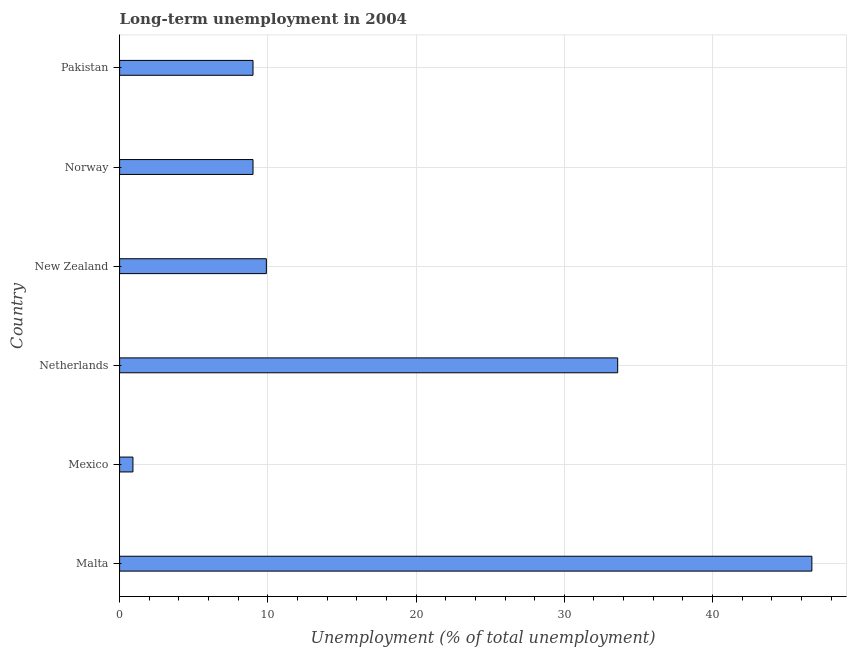Does the graph contain any zero values?
Provide a succinct answer. No. What is the title of the graph?
Your response must be concise. Long-term unemployment in 2004. What is the label or title of the X-axis?
Your answer should be very brief. Unemployment (% of total unemployment). What is the label or title of the Y-axis?
Make the answer very short. Country. What is the long-term unemployment in Mexico?
Ensure brevity in your answer.  0.9. Across all countries, what is the maximum long-term unemployment?
Ensure brevity in your answer.  46.7. Across all countries, what is the minimum long-term unemployment?
Your answer should be compact. 0.9. In which country was the long-term unemployment maximum?
Ensure brevity in your answer.  Malta. In which country was the long-term unemployment minimum?
Make the answer very short. Mexico. What is the sum of the long-term unemployment?
Provide a succinct answer. 109.1. What is the average long-term unemployment per country?
Your answer should be very brief. 18.18. What is the median long-term unemployment?
Give a very brief answer. 9.45. What is the ratio of the long-term unemployment in Mexico to that in Norway?
Offer a very short reply. 0.1. What is the difference between the highest and the second highest long-term unemployment?
Offer a very short reply. 13.1. Is the sum of the long-term unemployment in Netherlands and New Zealand greater than the maximum long-term unemployment across all countries?
Offer a terse response. No. What is the difference between the highest and the lowest long-term unemployment?
Make the answer very short. 45.8. In how many countries, is the long-term unemployment greater than the average long-term unemployment taken over all countries?
Your response must be concise. 2. Are all the bars in the graph horizontal?
Ensure brevity in your answer.  Yes. How many countries are there in the graph?
Your answer should be compact. 6. Are the values on the major ticks of X-axis written in scientific E-notation?
Ensure brevity in your answer.  No. What is the Unemployment (% of total unemployment) in Malta?
Give a very brief answer. 46.7. What is the Unemployment (% of total unemployment) of Mexico?
Keep it short and to the point. 0.9. What is the Unemployment (% of total unemployment) in Netherlands?
Your answer should be compact. 33.6. What is the Unemployment (% of total unemployment) of New Zealand?
Your answer should be compact. 9.9. What is the Unemployment (% of total unemployment) in Norway?
Keep it short and to the point. 9. What is the difference between the Unemployment (% of total unemployment) in Malta and Mexico?
Offer a very short reply. 45.8. What is the difference between the Unemployment (% of total unemployment) in Malta and New Zealand?
Your response must be concise. 36.8. What is the difference between the Unemployment (% of total unemployment) in Malta and Norway?
Ensure brevity in your answer.  37.7. What is the difference between the Unemployment (% of total unemployment) in Malta and Pakistan?
Offer a terse response. 37.7. What is the difference between the Unemployment (% of total unemployment) in Mexico and Netherlands?
Your answer should be very brief. -32.7. What is the difference between the Unemployment (% of total unemployment) in Netherlands and New Zealand?
Your answer should be very brief. 23.7. What is the difference between the Unemployment (% of total unemployment) in Netherlands and Norway?
Your response must be concise. 24.6. What is the difference between the Unemployment (% of total unemployment) in Netherlands and Pakistan?
Your response must be concise. 24.6. What is the difference between the Unemployment (% of total unemployment) in New Zealand and Norway?
Provide a succinct answer. 0.9. What is the difference between the Unemployment (% of total unemployment) in New Zealand and Pakistan?
Provide a succinct answer. 0.9. What is the difference between the Unemployment (% of total unemployment) in Norway and Pakistan?
Your answer should be very brief. 0. What is the ratio of the Unemployment (% of total unemployment) in Malta to that in Mexico?
Offer a terse response. 51.89. What is the ratio of the Unemployment (% of total unemployment) in Malta to that in Netherlands?
Offer a very short reply. 1.39. What is the ratio of the Unemployment (% of total unemployment) in Malta to that in New Zealand?
Keep it short and to the point. 4.72. What is the ratio of the Unemployment (% of total unemployment) in Malta to that in Norway?
Provide a succinct answer. 5.19. What is the ratio of the Unemployment (% of total unemployment) in Malta to that in Pakistan?
Your answer should be very brief. 5.19. What is the ratio of the Unemployment (% of total unemployment) in Mexico to that in Netherlands?
Give a very brief answer. 0.03. What is the ratio of the Unemployment (% of total unemployment) in Mexico to that in New Zealand?
Keep it short and to the point. 0.09. What is the ratio of the Unemployment (% of total unemployment) in Netherlands to that in New Zealand?
Give a very brief answer. 3.39. What is the ratio of the Unemployment (% of total unemployment) in Netherlands to that in Norway?
Offer a terse response. 3.73. What is the ratio of the Unemployment (% of total unemployment) in Netherlands to that in Pakistan?
Your response must be concise. 3.73. What is the ratio of the Unemployment (% of total unemployment) in New Zealand to that in Norway?
Offer a very short reply. 1.1. 